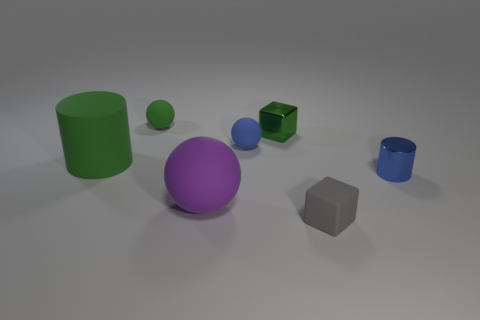Add 3 large cylinders. How many objects exist? 10 Subtract all balls. How many objects are left? 4 Add 6 small metal blocks. How many small metal blocks exist? 7 Subtract 0 red cylinders. How many objects are left? 7 Subtract all yellow cubes. Subtract all tiny blue rubber objects. How many objects are left? 6 Add 2 big purple things. How many big purple things are left? 3 